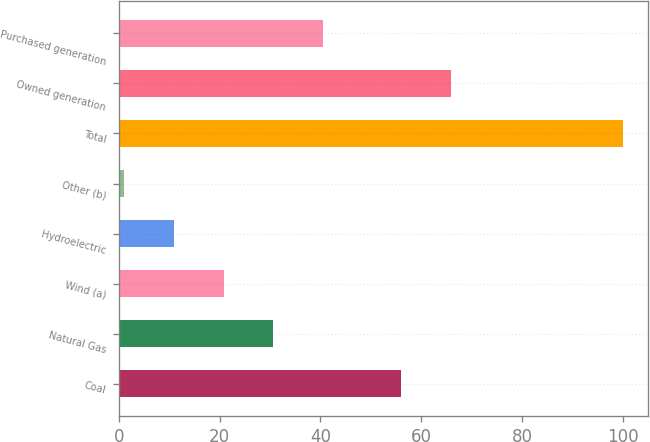Convert chart. <chart><loc_0><loc_0><loc_500><loc_500><bar_chart><fcel>Coal<fcel>Natural Gas<fcel>Wind (a)<fcel>Hydroelectric<fcel>Other (b)<fcel>Total<fcel>Owned generation<fcel>Purchased generation<nl><fcel>56<fcel>30.7<fcel>20.8<fcel>10.9<fcel>1<fcel>100<fcel>66<fcel>40.6<nl></chart> 